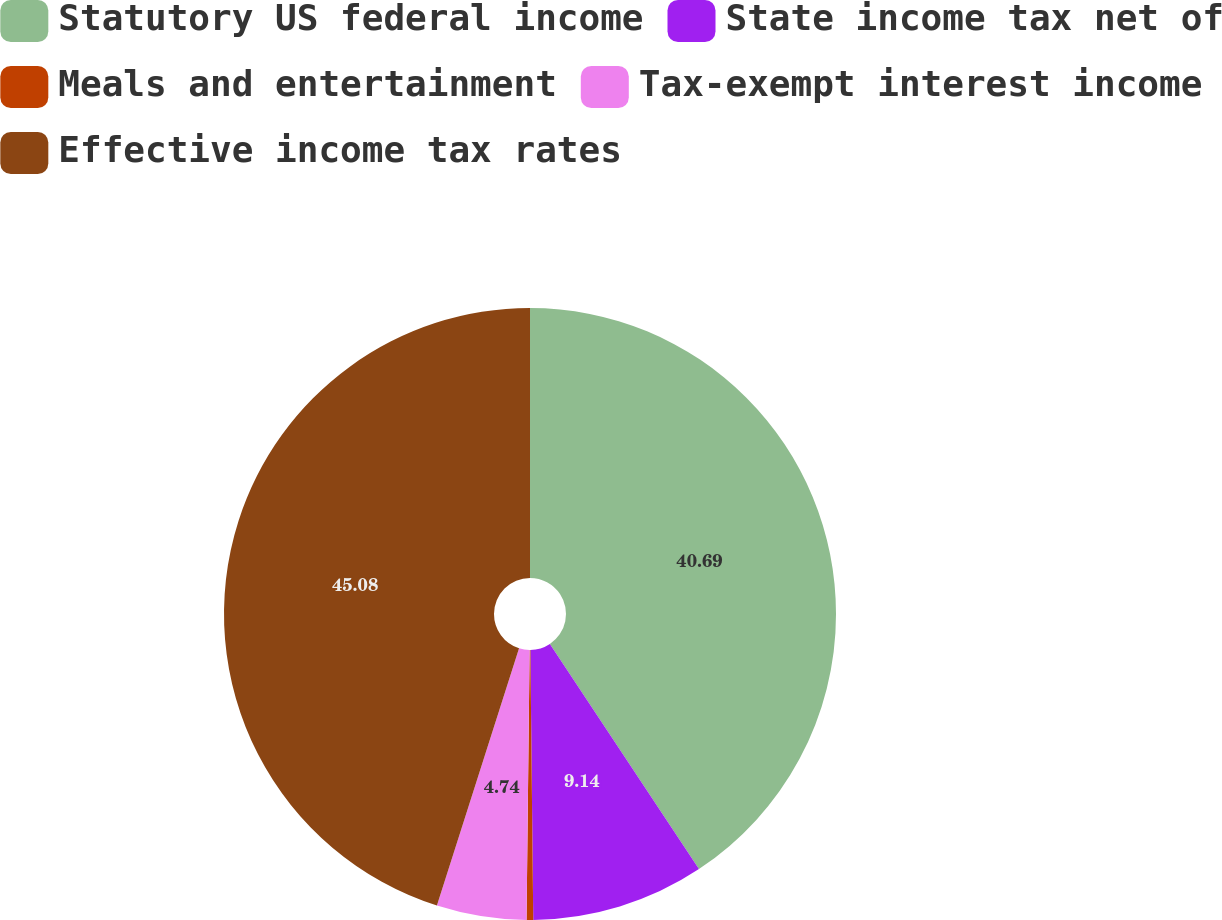Convert chart. <chart><loc_0><loc_0><loc_500><loc_500><pie_chart><fcel>Statutory US federal income<fcel>State income tax net of<fcel>Meals and entertainment<fcel>Tax-exempt interest income<fcel>Effective income tax rates<nl><fcel>40.69%<fcel>9.14%<fcel>0.35%<fcel>4.74%<fcel>45.08%<nl></chart> 